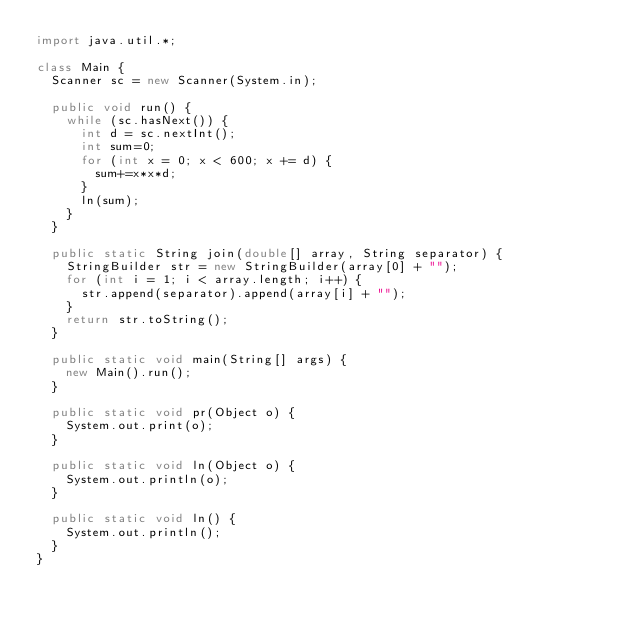<code> <loc_0><loc_0><loc_500><loc_500><_Java_>import java.util.*;

class Main {
	Scanner sc = new Scanner(System.in);

	public void run() {
		while (sc.hasNext()) {
			int d = sc.nextInt();
			int sum=0;
			for (int x = 0; x < 600; x += d) {
				sum+=x*x*d;
			}
			ln(sum);
		}
	}

	public static String join(double[] array, String separator) {
		StringBuilder str = new StringBuilder(array[0] + "");
		for (int i = 1; i < array.length; i++) {
			str.append(separator).append(array[i] + "");
		}
		return str.toString();
	}

	public static void main(String[] args) {
		new Main().run();
	}

	public static void pr(Object o) {
		System.out.print(o);
	}

	public static void ln(Object o) {
		System.out.println(o);
	}

	public static void ln() {
		System.out.println();
	}
}</code> 